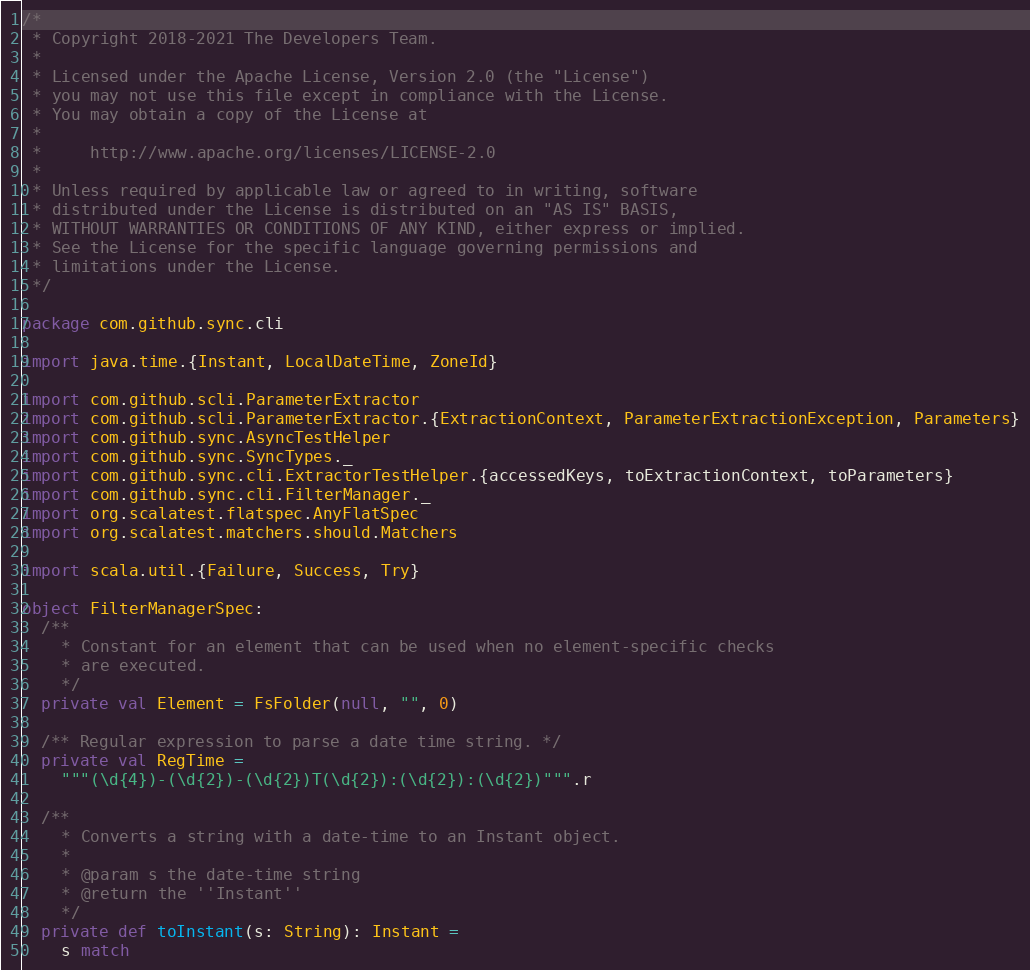<code> <loc_0><loc_0><loc_500><loc_500><_Scala_>/*
 * Copyright 2018-2021 The Developers Team.
 *
 * Licensed under the Apache License, Version 2.0 (the "License")
 * you may not use this file except in compliance with the License.
 * You may obtain a copy of the License at
 *
 *     http://www.apache.org/licenses/LICENSE-2.0
 *
 * Unless required by applicable law or agreed to in writing, software
 * distributed under the License is distributed on an "AS IS" BASIS,
 * WITHOUT WARRANTIES OR CONDITIONS OF ANY KIND, either express or implied.
 * See the License for the specific language governing permissions and
 * limitations under the License.
 */

package com.github.sync.cli

import java.time.{Instant, LocalDateTime, ZoneId}

import com.github.scli.ParameterExtractor
import com.github.scli.ParameterExtractor.{ExtractionContext, ParameterExtractionException, Parameters}
import com.github.sync.AsyncTestHelper
import com.github.sync.SyncTypes._
import com.github.sync.cli.ExtractorTestHelper.{accessedKeys, toExtractionContext, toParameters}
import com.github.sync.cli.FilterManager._
import org.scalatest.flatspec.AnyFlatSpec
import org.scalatest.matchers.should.Matchers

import scala.util.{Failure, Success, Try}

object FilterManagerSpec:
  /**
    * Constant for an element that can be used when no element-specific checks
    * are executed.
    */
  private val Element = FsFolder(null, "", 0)

  /** Regular expression to parse a date time string. */
  private val RegTime =
    """(\d{4})-(\d{2})-(\d{2})T(\d{2}):(\d{2}):(\d{2})""".r

  /**
    * Converts a string with a date-time to an Instant object.
    *
    * @param s the date-time string
    * @return the ''Instant''
    */
  private def toInstant(s: String): Instant =
    s match</code> 